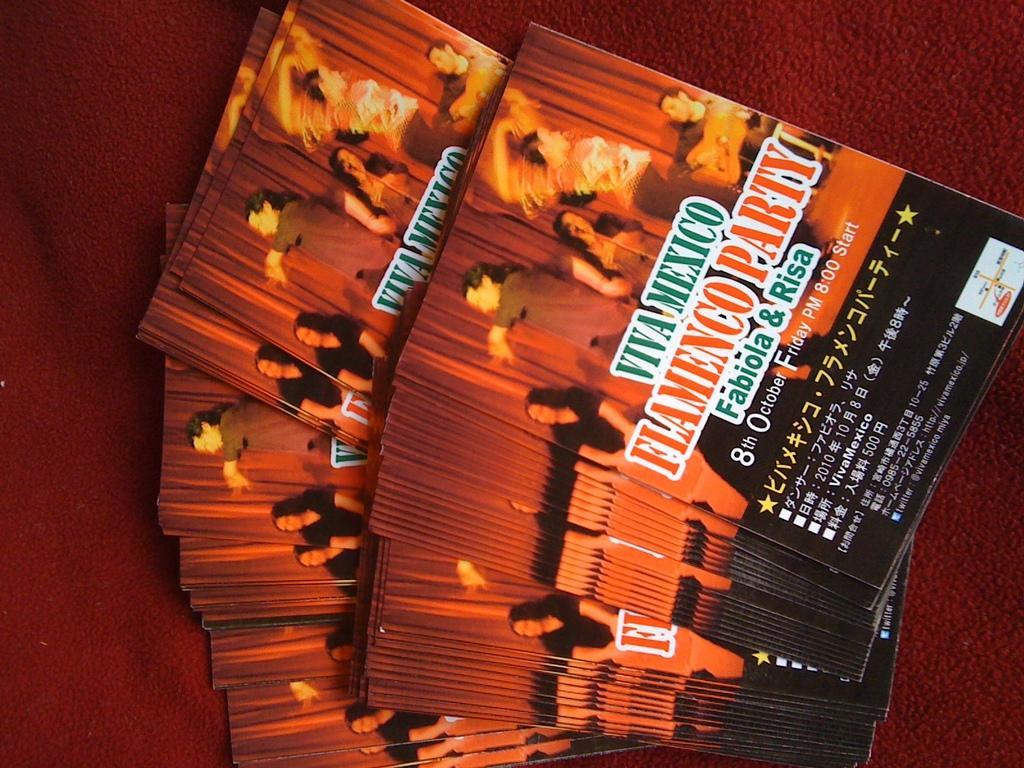Describe this image in one or two sentences. In the image there is a collection of books kept on a maroon cloth, there are some images and texts on the cover page of the books. 